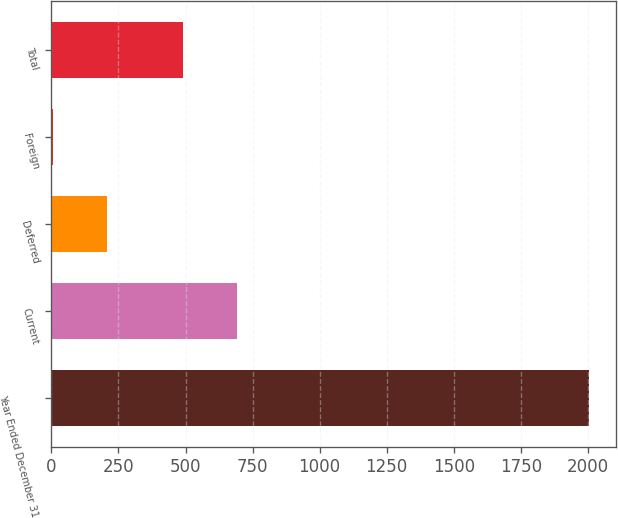<chart> <loc_0><loc_0><loc_500><loc_500><bar_chart><fcel>Year Ended December 31<fcel>Current<fcel>Deferred<fcel>Foreign<fcel>Total<nl><fcel>2005<fcel>690.32<fcel>205.72<fcel>5.8<fcel>490.4<nl></chart> 